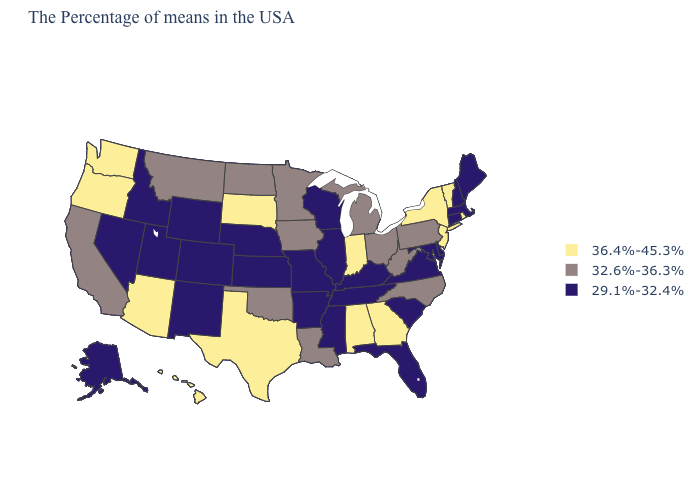Name the states that have a value in the range 36.4%-45.3%?
Answer briefly. Rhode Island, Vermont, New York, New Jersey, Georgia, Indiana, Alabama, Texas, South Dakota, Arizona, Washington, Oregon, Hawaii. Among the states that border Oklahoma , does Colorado have the highest value?
Keep it brief. No. Among the states that border Connecticut , which have the highest value?
Quick response, please. Rhode Island, New York. Does the first symbol in the legend represent the smallest category?
Give a very brief answer. No. What is the lowest value in the USA?
Be succinct. 29.1%-32.4%. How many symbols are there in the legend?
Answer briefly. 3. What is the value of Ohio?
Keep it brief. 32.6%-36.3%. What is the value of Massachusetts?
Give a very brief answer. 29.1%-32.4%. What is the value of Kentucky?
Answer briefly. 29.1%-32.4%. What is the highest value in the USA?
Give a very brief answer. 36.4%-45.3%. Which states have the lowest value in the USA?
Quick response, please. Maine, Massachusetts, New Hampshire, Connecticut, Delaware, Maryland, Virginia, South Carolina, Florida, Kentucky, Tennessee, Wisconsin, Illinois, Mississippi, Missouri, Arkansas, Kansas, Nebraska, Wyoming, Colorado, New Mexico, Utah, Idaho, Nevada, Alaska. What is the value of Delaware?
Quick response, please. 29.1%-32.4%. Name the states that have a value in the range 36.4%-45.3%?
Be succinct. Rhode Island, Vermont, New York, New Jersey, Georgia, Indiana, Alabama, Texas, South Dakota, Arizona, Washington, Oregon, Hawaii. Does Kansas have the highest value in the USA?
Give a very brief answer. No. Name the states that have a value in the range 29.1%-32.4%?
Write a very short answer. Maine, Massachusetts, New Hampshire, Connecticut, Delaware, Maryland, Virginia, South Carolina, Florida, Kentucky, Tennessee, Wisconsin, Illinois, Mississippi, Missouri, Arkansas, Kansas, Nebraska, Wyoming, Colorado, New Mexico, Utah, Idaho, Nevada, Alaska. 